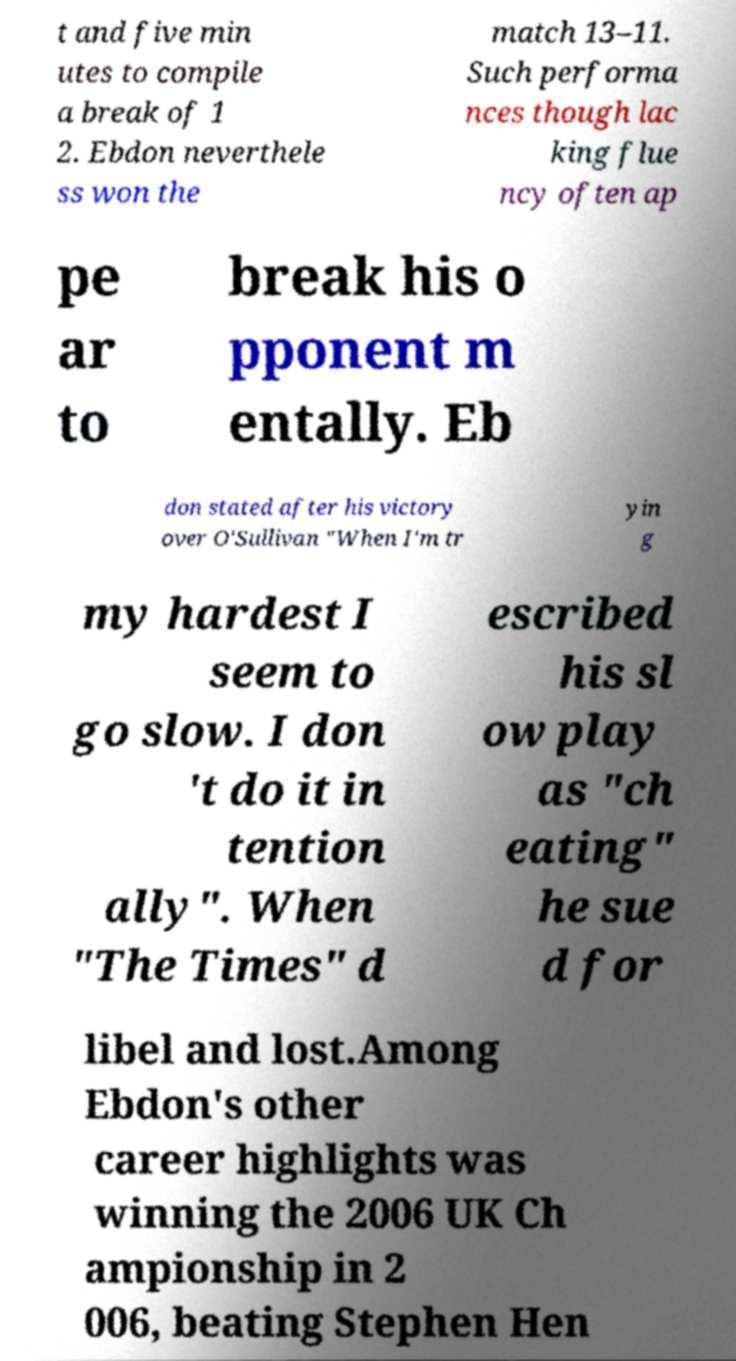What messages or text are displayed in this image? I need them in a readable, typed format. t and five min utes to compile a break of 1 2. Ebdon neverthele ss won the match 13–11. Such performa nces though lac king flue ncy often ap pe ar to break his o pponent m entally. Eb don stated after his victory over O'Sullivan "When I'm tr yin g my hardest I seem to go slow. I don 't do it in tention ally". When "The Times" d escribed his sl ow play as "ch eating" he sue d for libel and lost.Among Ebdon's other career highlights was winning the 2006 UK Ch ampionship in 2 006, beating Stephen Hen 